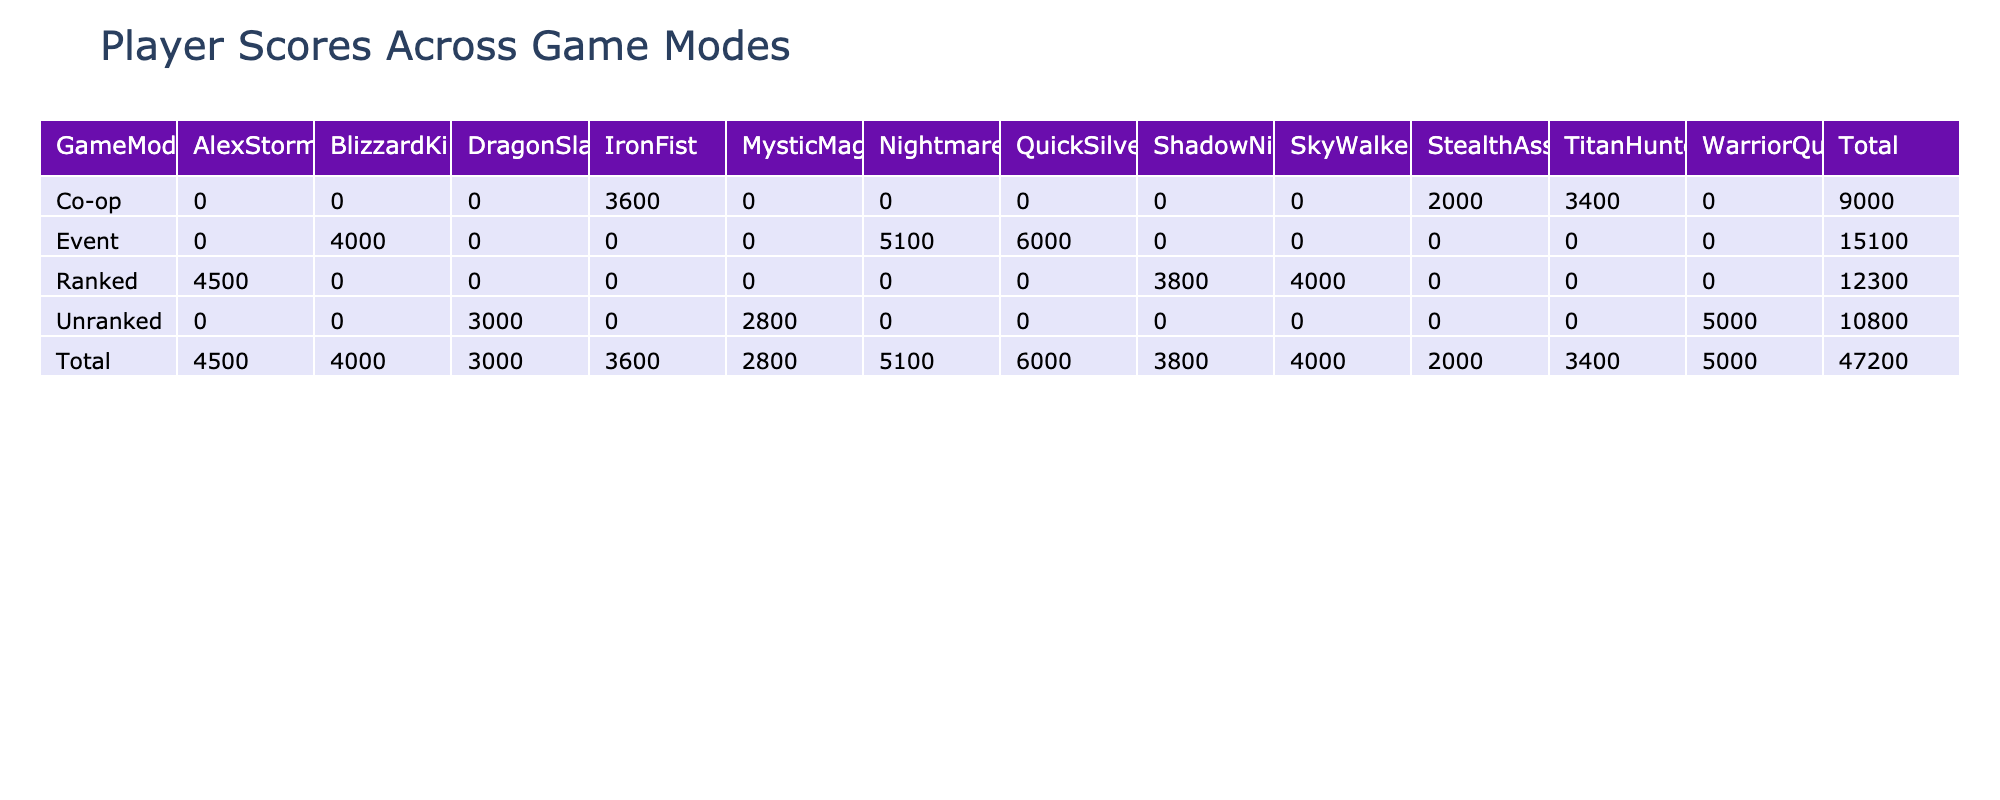What is the total score of ShadowNinja in Ranked mode? In the table, under the Ranked game mode, the score for ShadowNinja is 3800, so the total score for ShadowNinja in that mode is directly taken from the cell corresponding to ShadowNinja in the Ranked row.
Answer: 3800 Which player has the highest score in Event mode? Looking at the Event game mode, we see QuickSilver has the highest score of 6000, which is the maximum value in that row compared to NightmareAce and BlizzardKing.
Answer: QuickSilver What is the average score of players in Unranked mode? The scores for players in Unranked mode are 3000 (DragonSlayer), 5000 (WarriorQueen), and 2800 (MysticMage). The average score can be calculated by summing these scores (3000 + 5000 + 2800) = 10800 and then dividing by the number of players (3): 10800 / 3 = 3600.
Answer: 3600 Did any player achieve more than 20 kills in Co-op mode? In the table, looking at the Co-op mode, the players have 16 kills (StealthAssassin), 28 kills (TitanHunter), and 22 kills (IronFist). Since both TitanHunter and IronFist scored more than 20 kills, the answer is yes.
Answer: Yes What is the difference between the total scores of Ranked mode and Unranked mode? The total scores in Ranked mode are calculated by summing the scores of the players: 4500 (AlexStorm) + 4000 (SkyWalker) + 3800 (ShadowNinja) = 12300. In Unranked mode, the total scores are 3000 + 5000 + 2800 = 10800. The difference is 12300 - 10800 = 1500.
Answer: 1500 Which game mode has the lowest total score? First, we need to calculate the total scores for each game mode: Ranked = 12300, Unranked = 10800, Co-op = 2000 + 3400 + 3600 = 9000, Event = 6000 + 5100 + 4000 = 15100. Among these, Unranked mode has the lowest total score of 10800 when compared to the other totals.
Answer: Unranked How many players have more than 15 assists in total? In the table, counting the assists for each player, ShadowNinja has 8, WarriorQueen has 12, StealthAssassin has 5, TitanHunter has 10, IronFist has 15, QuickSilver has 25, NightmareAce has 20, and BlizzardKing has 15. The players with more than 15 assists are QuickSilver (25) and NightmareAce (20). Therefore, there are 2 players with more than 15 assists.
Answer: 2 What is the total number of deaths by players in Ranked mode? In Ranked mode, we sum the deaths: AlexStorm has 8, SkyWalker has 5, and ShadowNinja has 10. So, the total deaths calculated is 8 + 5 + 10 = 23.
Answer: 23 Who is the player with the lowest score in Co-op mode? In the Co-op mode, the scores are 2000 (StealthAssassin), 3400 (TitanHunter), and 3600 (IronFist). The player with the lowest score among them is StealthAssassin with a score of 2000.
Answer: StealthAssassin 